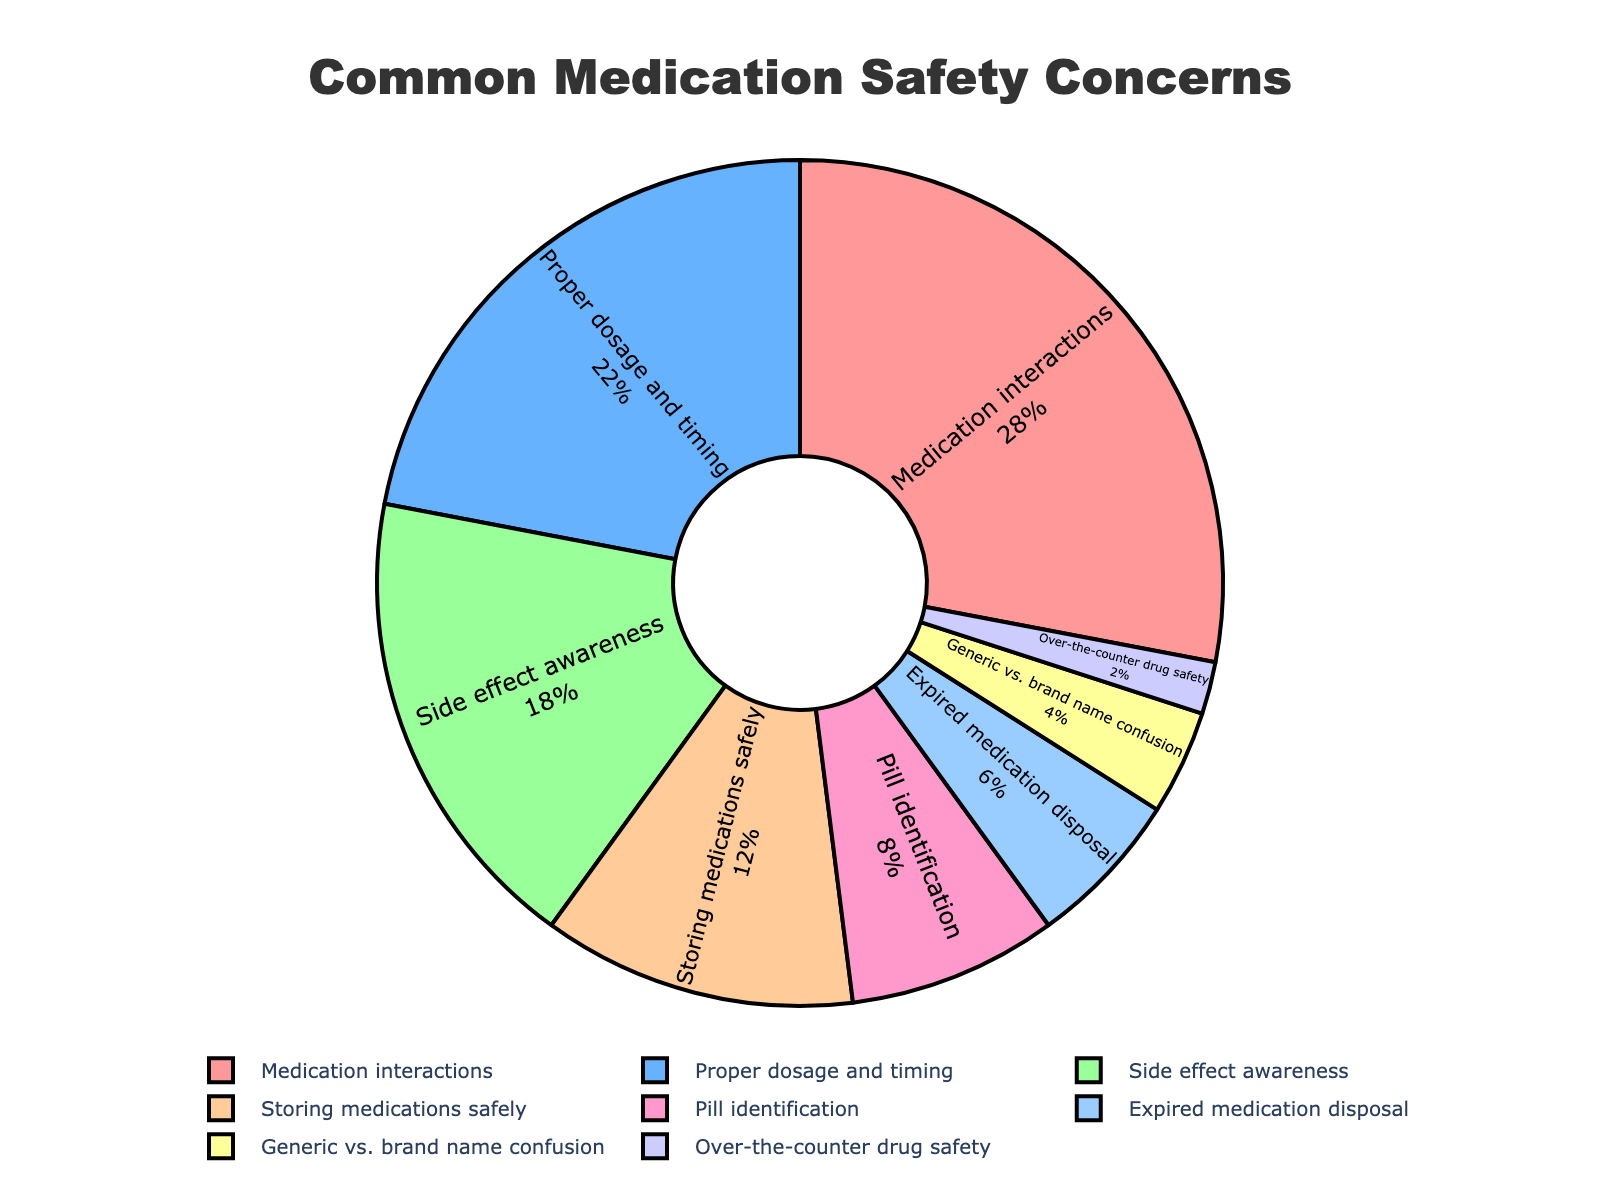Which category has the highest percentage of concern among local residents? By looking at the pie chart, we can identify the segment with the largest percentage value labeled. The slice labeled "Medication interactions" shows the highest percentage.
Answer: Medication interactions What's the total percentage for the top three medication safety concerns? Locate the top three highest percentage slices in the chart and add their values together: Medication interactions (28%) + Proper dosage and timing (22%) + Side effect awareness (18%) = 28% + 22% + 18%
Answer: 68% Which is of greater concern among residents: Proper dosage and timing or Storing medications safely? Compare the percentages of "Proper dosage and timing" and "Storing medications safely" as shown on the pie chart. Proper dosage and timing has 22%, whereas storing medications safely has 12%.
Answer: Proper dosage and timing What is the combined percentage for the concerns related to Pill identification, Expired medication disposal, Generic vs. brand name confusion, and Over-the-counter drug safety? Identify the percentages for each concern and sum them: Pill identification (8%) + Expired medication disposal (6%) + Generic vs. brand name confusion (4%) + Over-the-counter drug safety (2%) = 8% + 6% + 4% + 2%
Answer: 20% What visual attribute can help you identify the category "Over-the-counter drug safety" in the pie chart? "Over-the-counter drug safety" can be identified by its small slice in the pie chart, with the percentage value of 2% and located next to the slightly larger slice labeled "Generic vs. brand name confusion".
Answer: Small slice with 2% If the percentages of each category were represented by smaller or larger slices based on their numerical values, which category slice would you expect to see as the second largest? Since the second-largest percentage value in the chart is 22%, the slice labeled "Proper dosage and timing" would be expected to be the second largest.
Answer: Proper dosage and timing How does the percentage for 'Pill identification' compare to 'Over-the-counter drug safety'? The percentage for "Pill identification" is 8% and for "Over-the-counter drug safety" is 2%. Comparing the two, 8% is greater than 2%.
Answer: Pill identification is greater What percentage of concerns is taken by issues not including "Medication interactions", "Proper dosage and timing", and "Side effect awareness"? Calculate the total percentage of all segments and subtract the combined percentage of the three categories: 100% - (28% + 22% + 18%) = 100% - 68%
Answer: 32% What's the difference in percentage between 'Storing medications safely' and 'Expired medication disposal'? Subtract the percentage for "Expired medication disposal" from "Storing medications safely": 12% - 6% = 6%
Answer: 6% If you combine the less concerning categories ('Expired medication disposal', 'Generic vs. brand name confusion', and 'Over-the-counter drug safety'), would their total be greater than 'Side effect awareness'? Sum the percentages of the less concerning categories and compare with 'Side effect awareness'. 6% + 4% + 2% = 12%, which is less than 18%.
Answer: No 